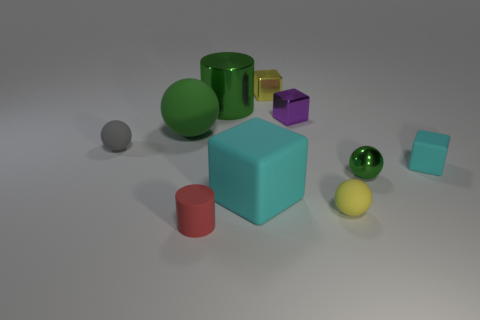What is the color of the tiny ball behind the small green metal thing?
Your answer should be very brief. Gray. There is a gray thing that is the same size as the red thing; what is its shape?
Provide a short and direct response. Sphere. There is a large matte cube; is its color the same as the tiny shiny block behind the purple object?
Keep it short and to the point. No. How many objects are matte balls that are behind the tiny gray matte ball or metallic objects that are in front of the yellow metal cube?
Make the answer very short. 4. There is a yellow ball that is the same size as the gray matte thing; what is its material?
Provide a short and direct response. Rubber. How many other things are there of the same material as the big cyan thing?
Ensure brevity in your answer.  5. There is a shiny thing that is to the left of the yellow metal block; is it the same shape as the large matte object that is to the right of the big green ball?
Provide a succinct answer. No. What is the color of the big thing in front of the big rubber ball behind the yellow thing that is in front of the purple metal cube?
Your answer should be very brief. Cyan. How many other things are there of the same color as the large cube?
Make the answer very short. 1. Is the number of tiny things less than the number of yellow cylinders?
Provide a short and direct response. No. 